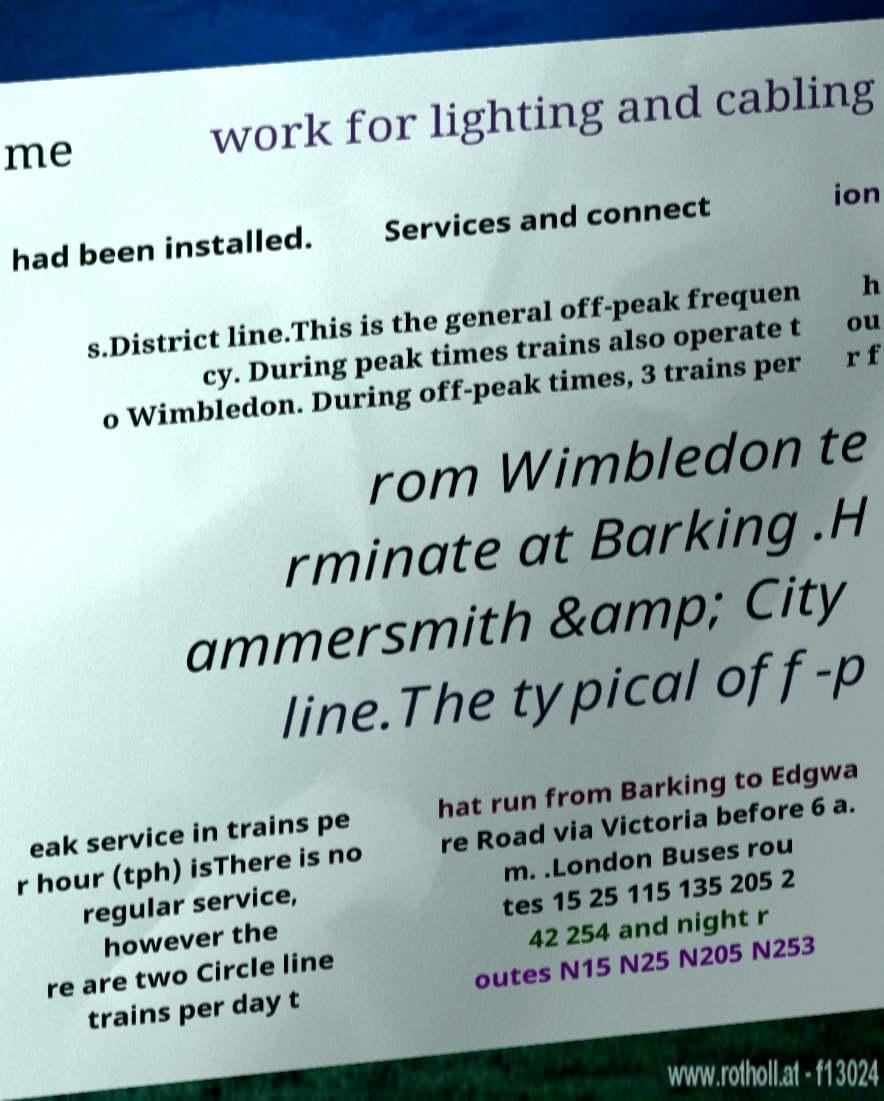For documentation purposes, I need the text within this image transcribed. Could you provide that? me work for lighting and cabling had been installed. Services and connect ion s.District line.This is the general off-peak frequen cy. During peak times trains also operate t o Wimbledon. During off-peak times, 3 trains per h ou r f rom Wimbledon te rminate at Barking .H ammersmith &amp; City line.The typical off-p eak service in trains pe r hour (tph) isThere is no regular service, however the re are two Circle line trains per day t hat run from Barking to Edgwa re Road via Victoria before 6 a. m. .London Buses rou tes 15 25 115 135 205 2 42 254 and night r outes N15 N25 N205 N253 